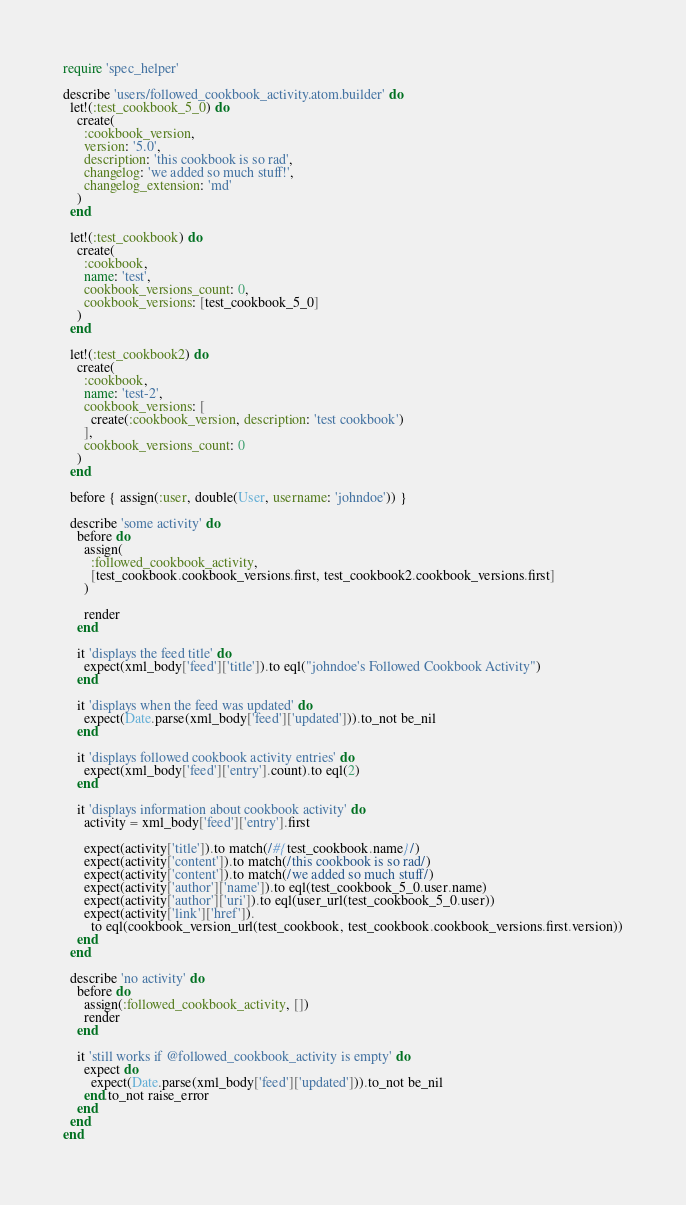Convert code to text. <code><loc_0><loc_0><loc_500><loc_500><_Ruby_>require 'spec_helper'

describe 'users/followed_cookbook_activity.atom.builder' do
  let!(:test_cookbook_5_0) do
    create(
      :cookbook_version,
      version: '5.0',
      description: 'this cookbook is so rad',
      changelog: 'we added so much stuff!',
      changelog_extension: 'md'
    )
  end

  let!(:test_cookbook) do
    create(
      :cookbook,
      name: 'test',
      cookbook_versions_count: 0,
      cookbook_versions: [test_cookbook_5_0]
    )
  end

  let!(:test_cookbook2) do
    create(
      :cookbook,
      name: 'test-2',
      cookbook_versions: [
        create(:cookbook_version, description: 'test cookbook')
      ],
      cookbook_versions_count: 0
    )
  end

  before { assign(:user, double(User, username: 'johndoe')) }

  describe 'some activity' do
    before do
      assign(
        :followed_cookbook_activity,
        [test_cookbook.cookbook_versions.first, test_cookbook2.cookbook_versions.first]
      )

      render
    end

    it 'displays the feed title' do
      expect(xml_body['feed']['title']).to eql("johndoe's Followed Cookbook Activity")
    end

    it 'displays when the feed was updated' do
      expect(Date.parse(xml_body['feed']['updated'])).to_not be_nil
    end

    it 'displays followed cookbook activity entries' do
      expect(xml_body['feed']['entry'].count).to eql(2)
    end

    it 'displays information about cookbook activity' do
      activity = xml_body['feed']['entry'].first

      expect(activity['title']).to match(/#{test_cookbook.name}/)
      expect(activity['content']).to match(/this cookbook is so rad/)
      expect(activity['content']).to match(/we added so much stuff/)
      expect(activity['author']['name']).to eql(test_cookbook_5_0.user.name)
      expect(activity['author']['uri']).to eql(user_url(test_cookbook_5_0.user))
      expect(activity['link']['href']).
        to eql(cookbook_version_url(test_cookbook, test_cookbook.cookbook_versions.first.version))
    end
  end

  describe 'no activity' do
    before do
      assign(:followed_cookbook_activity, [])
      render
    end

    it 'still works if @followed_cookbook_activity is empty' do
      expect do
        expect(Date.parse(xml_body['feed']['updated'])).to_not be_nil
      end.to_not raise_error
    end
  end
end
</code> 